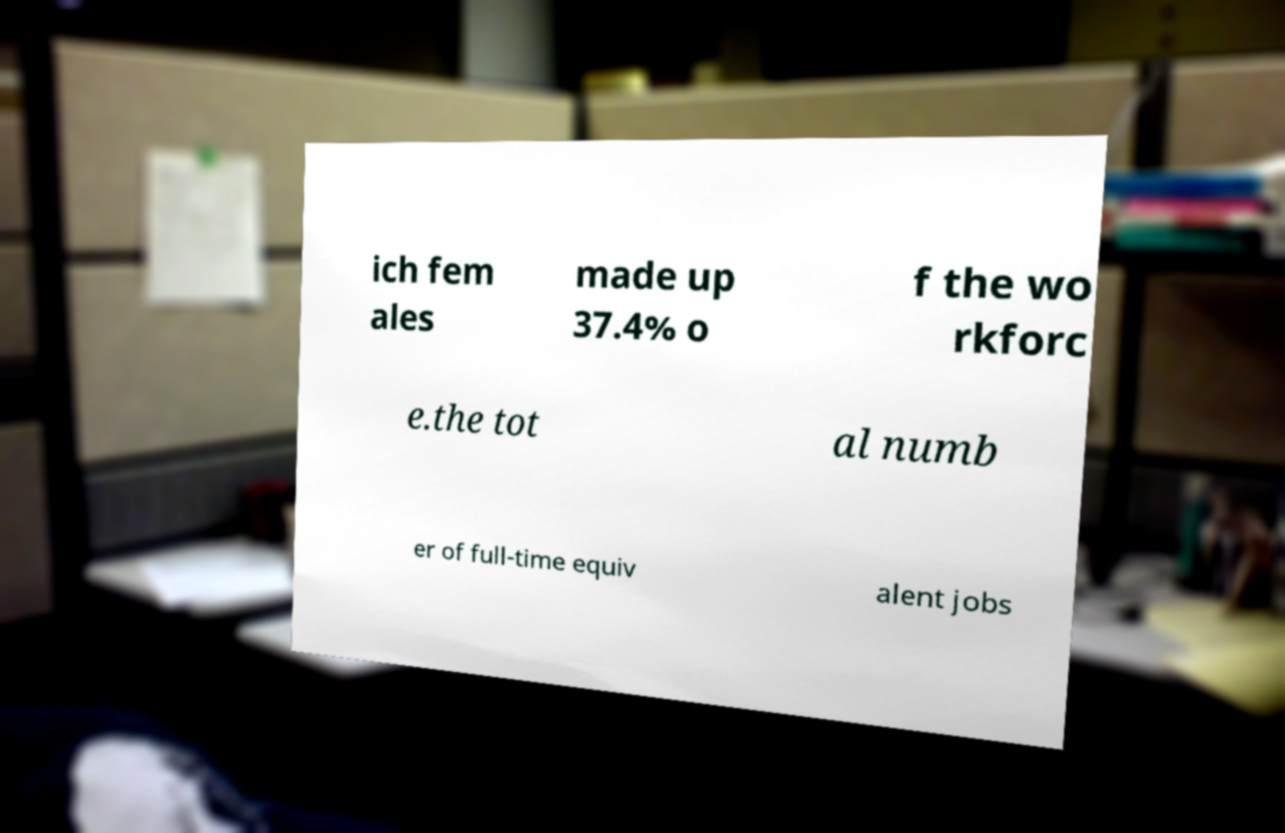Could you assist in decoding the text presented in this image and type it out clearly? ich fem ales made up 37.4% o f the wo rkforc e.the tot al numb er of full-time equiv alent jobs 